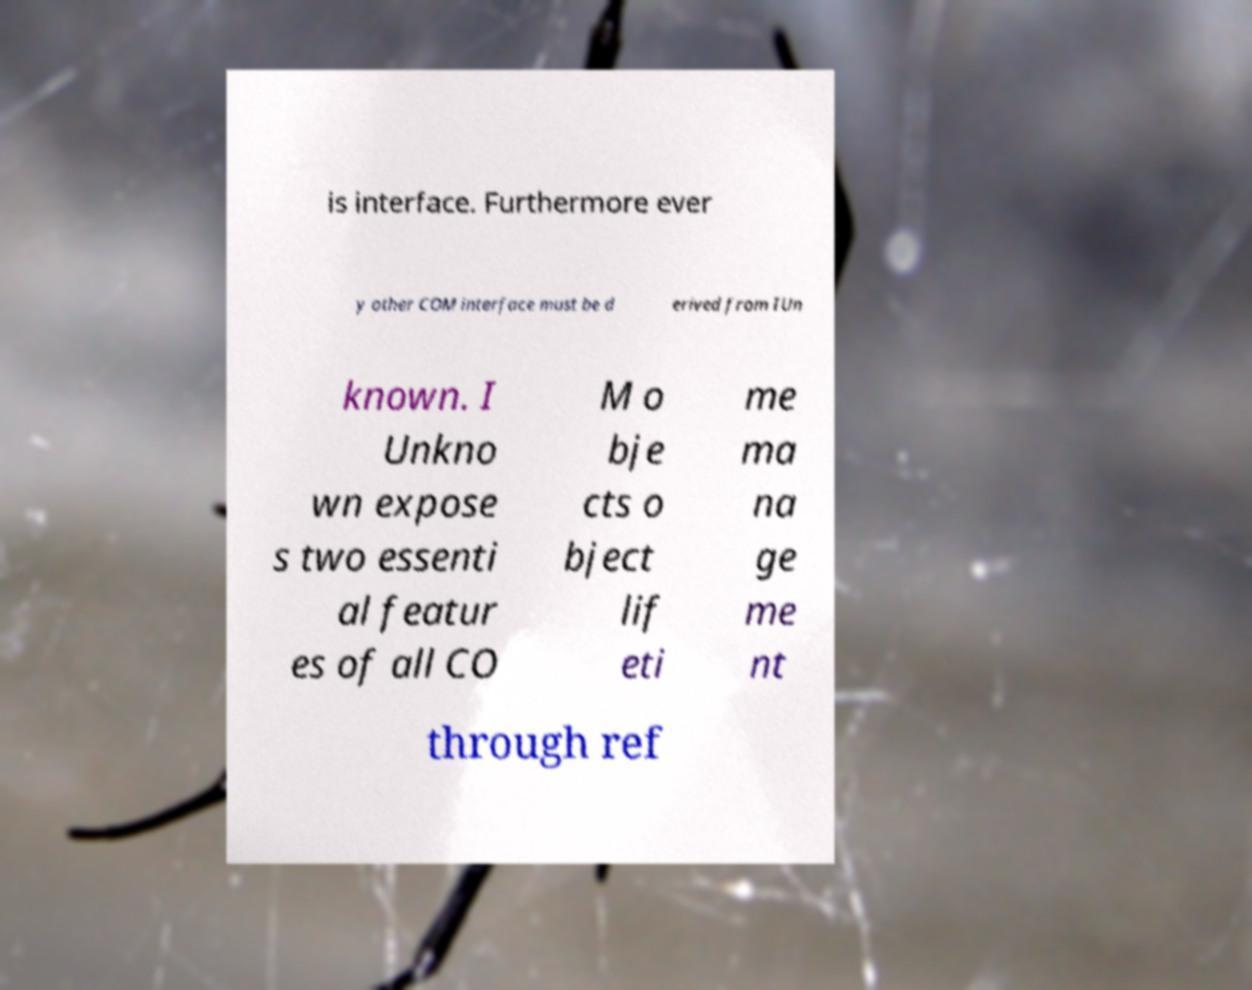There's text embedded in this image that I need extracted. Can you transcribe it verbatim? is interface. Furthermore ever y other COM interface must be d erived from IUn known. I Unkno wn expose s two essenti al featur es of all CO M o bje cts o bject lif eti me ma na ge me nt through ref 